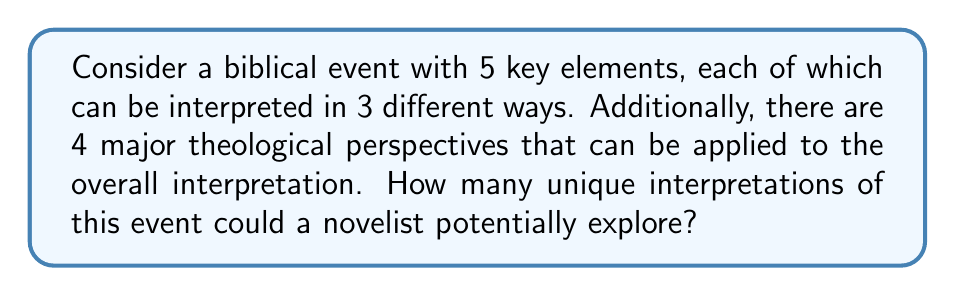Show me your answer to this math problem. Let's approach this step-by-step:

1. For each key element, there are 3 possible interpretations. This creates a combination problem.

2. The total number of ways to interpret all 5 elements is:
   $3 \times 3 \times 3 \times 3 \times 3 = 3^5 = 243$

3. This means there are 243 unique combinations of interpretations for the key elements.

4. Now, each of these 243 combinations can be viewed through 4 different theological perspectives.

5. To calculate the total number of unique interpretations, we multiply the number of element combinations by the number of theological perspectives:

   $243 \times 4 = 972$

Therefore, a novelist could potentially explore 972 unique interpretations of this biblical event.
Answer: 972 